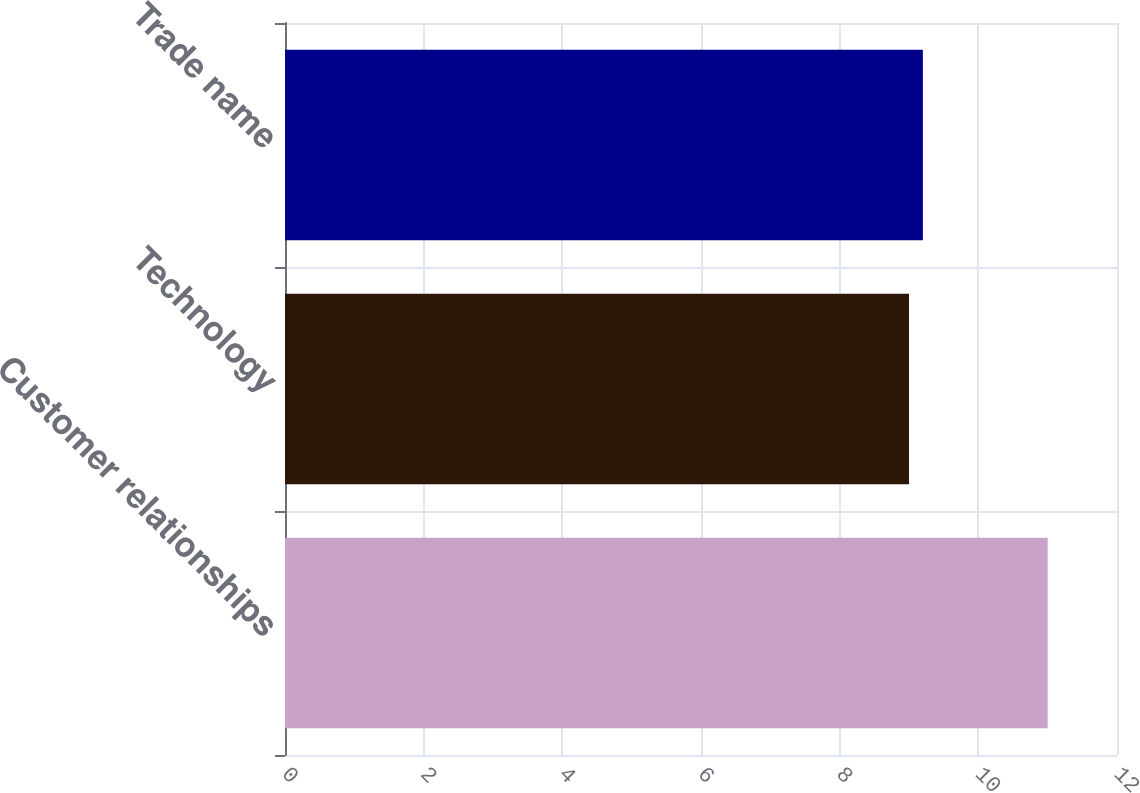<chart> <loc_0><loc_0><loc_500><loc_500><bar_chart><fcel>Customer relationships<fcel>Technology<fcel>Trade name<nl><fcel>11<fcel>9<fcel>9.2<nl></chart> 